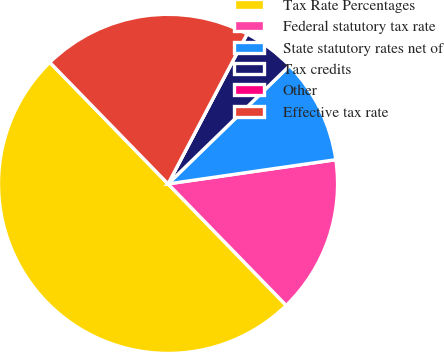<chart> <loc_0><loc_0><loc_500><loc_500><pie_chart><fcel>Tax Rate Percentages<fcel>Federal statutory tax rate<fcel>State statutory rates net of<fcel>Tax credits<fcel>Other<fcel>Effective tax rate<nl><fcel>49.99%<fcel>15.0%<fcel>10.0%<fcel>5.0%<fcel>0.0%<fcel>20.0%<nl></chart> 